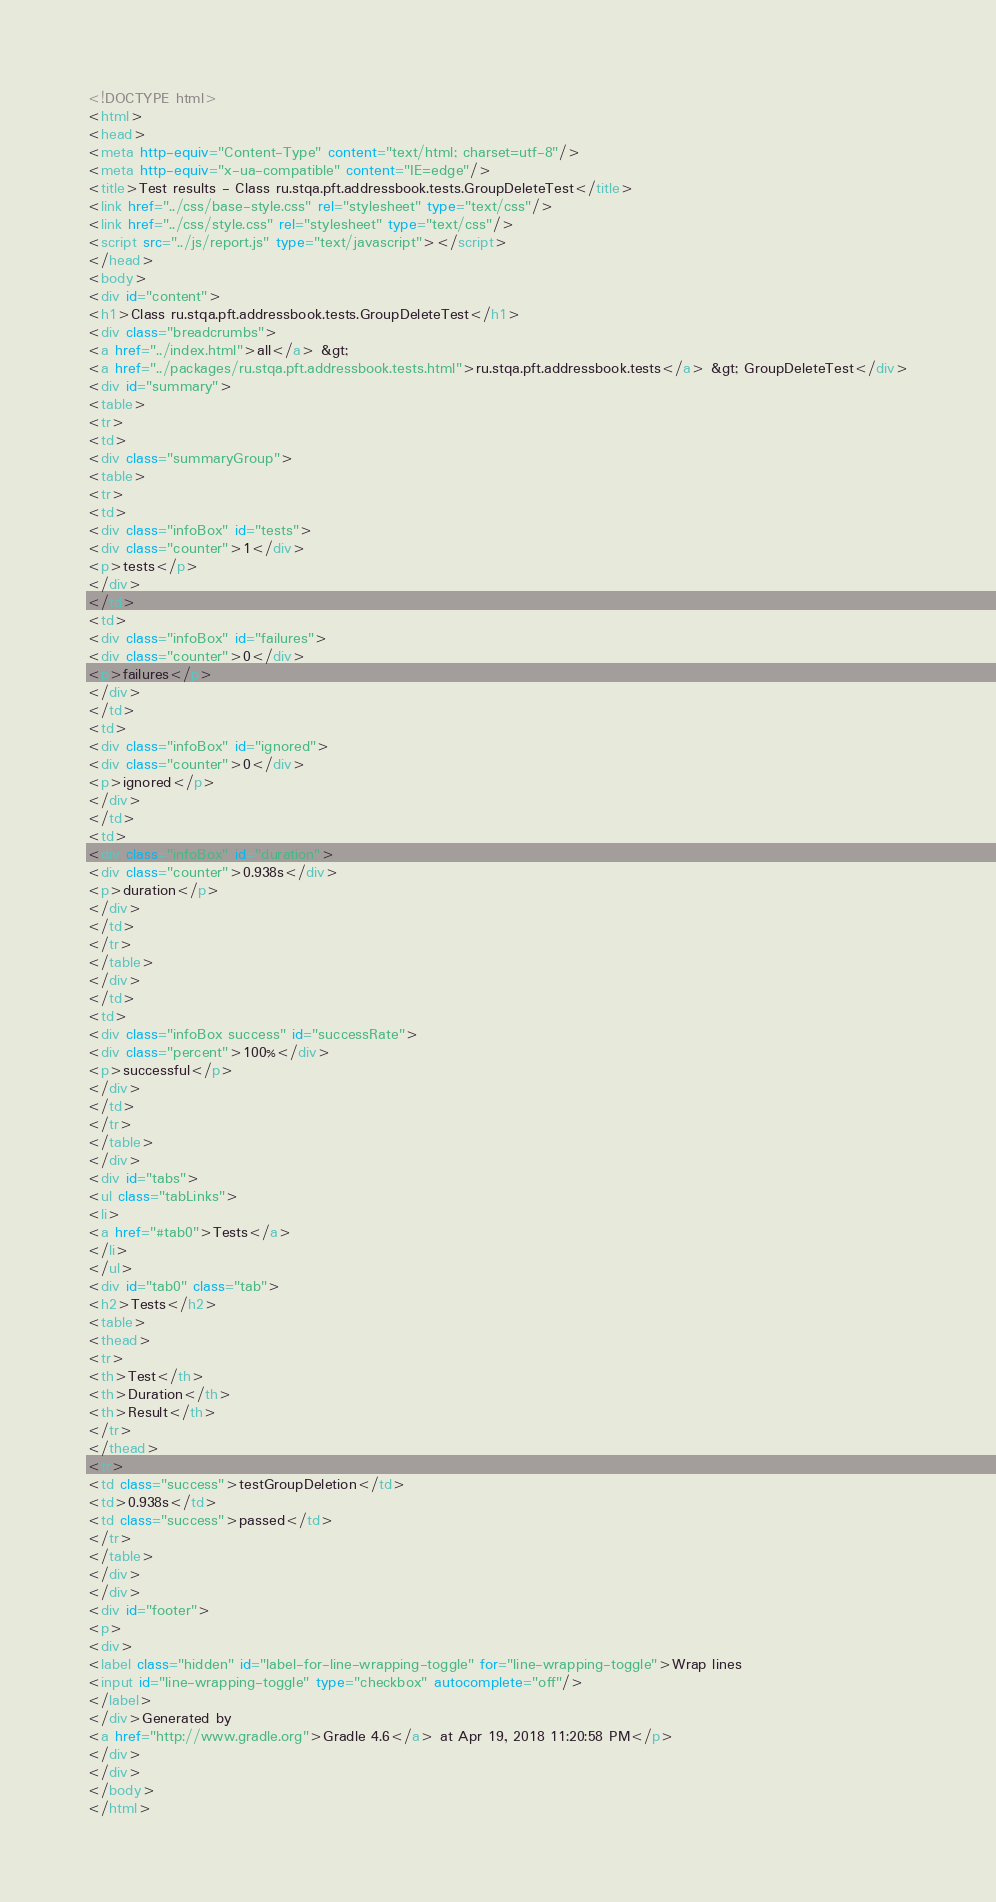Convert code to text. <code><loc_0><loc_0><loc_500><loc_500><_HTML_><!DOCTYPE html>
<html>
<head>
<meta http-equiv="Content-Type" content="text/html; charset=utf-8"/>
<meta http-equiv="x-ua-compatible" content="IE=edge"/>
<title>Test results - Class ru.stqa.pft.addressbook.tests.GroupDeleteTest</title>
<link href="../css/base-style.css" rel="stylesheet" type="text/css"/>
<link href="../css/style.css" rel="stylesheet" type="text/css"/>
<script src="../js/report.js" type="text/javascript"></script>
</head>
<body>
<div id="content">
<h1>Class ru.stqa.pft.addressbook.tests.GroupDeleteTest</h1>
<div class="breadcrumbs">
<a href="../index.html">all</a> &gt; 
<a href="../packages/ru.stqa.pft.addressbook.tests.html">ru.stqa.pft.addressbook.tests</a> &gt; GroupDeleteTest</div>
<div id="summary">
<table>
<tr>
<td>
<div class="summaryGroup">
<table>
<tr>
<td>
<div class="infoBox" id="tests">
<div class="counter">1</div>
<p>tests</p>
</div>
</td>
<td>
<div class="infoBox" id="failures">
<div class="counter">0</div>
<p>failures</p>
</div>
</td>
<td>
<div class="infoBox" id="ignored">
<div class="counter">0</div>
<p>ignored</p>
</div>
</td>
<td>
<div class="infoBox" id="duration">
<div class="counter">0.938s</div>
<p>duration</p>
</div>
</td>
</tr>
</table>
</div>
</td>
<td>
<div class="infoBox success" id="successRate">
<div class="percent">100%</div>
<p>successful</p>
</div>
</td>
</tr>
</table>
</div>
<div id="tabs">
<ul class="tabLinks">
<li>
<a href="#tab0">Tests</a>
</li>
</ul>
<div id="tab0" class="tab">
<h2>Tests</h2>
<table>
<thead>
<tr>
<th>Test</th>
<th>Duration</th>
<th>Result</th>
</tr>
</thead>
<tr>
<td class="success">testGroupDeletion</td>
<td>0.938s</td>
<td class="success">passed</td>
</tr>
</table>
</div>
</div>
<div id="footer">
<p>
<div>
<label class="hidden" id="label-for-line-wrapping-toggle" for="line-wrapping-toggle">Wrap lines
<input id="line-wrapping-toggle" type="checkbox" autocomplete="off"/>
</label>
</div>Generated by 
<a href="http://www.gradle.org">Gradle 4.6</a> at Apr 19, 2018 11:20:58 PM</p>
</div>
</div>
</body>
</html>
</code> 